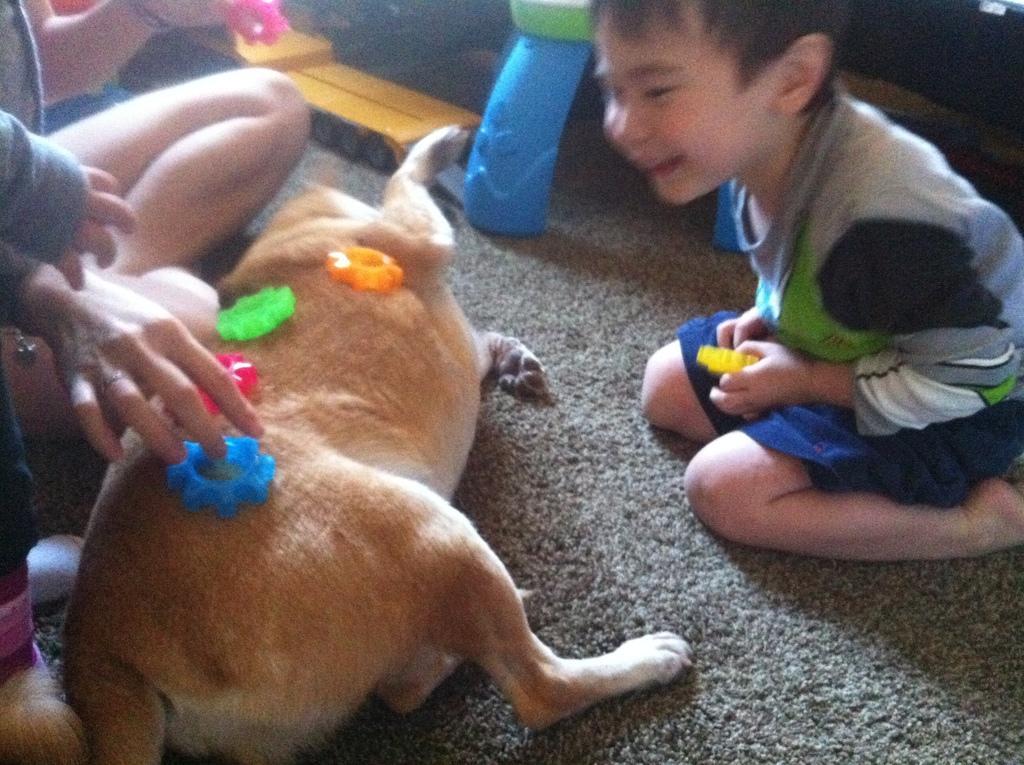In one or two sentences, can you explain what this image depicts? In this Image I see a boy who is sitting on the floor and there is a dog over here on which there are few things on it. I can also see another person over here and there are few toys over here. 